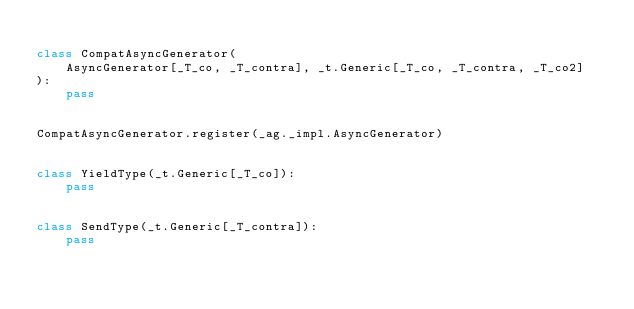<code> <loc_0><loc_0><loc_500><loc_500><_Python_>
class CompatAsyncGenerator(
    AsyncGenerator[_T_co, _T_contra], _t.Generic[_T_co, _T_contra, _T_co2]
):
    pass


CompatAsyncGenerator.register(_ag._impl.AsyncGenerator)


class YieldType(_t.Generic[_T_co]):
    pass


class SendType(_t.Generic[_T_contra]):
    pass
</code> 